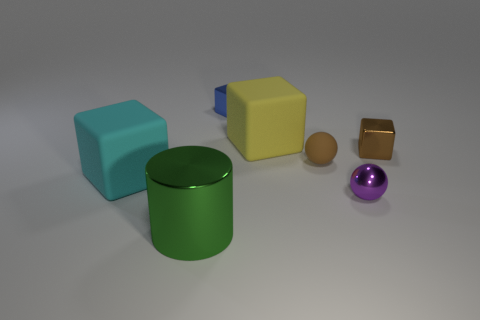There is a green thing; is its size the same as the rubber object that is right of the large yellow matte object?
Provide a succinct answer. No. What color is the tiny metal object on the right side of the tiny purple ball?
Your answer should be compact. Brown. How many gray things are either cylinders or tiny shiny balls?
Offer a terse response. 0. What color is the shiny ball?
Make the answer very short. Purple. Is there any other thing that has the same material as the green object?
Ensure brevity in your answer.  Yes. Are there fewer metal objects that are behind the tiny brown metallic thing than large cyan rubber cubes that are in front of the tiny blue shiny cube?
Your answer should be compact. No. The metal object that is in front of the tiny blue shiny block and behind the brown sphere has what shape?
Provide a succinct answer. Cube. What number of brown objects have the same shape as the big green object?
Your response must be concise. 0. There is a brown object that is made of the same material as the yellow object; what size is it?
Give a very brief answer. Small. What number of brown matte spheres have the same size as the green cylinder?
Offer a terse response. 0. 